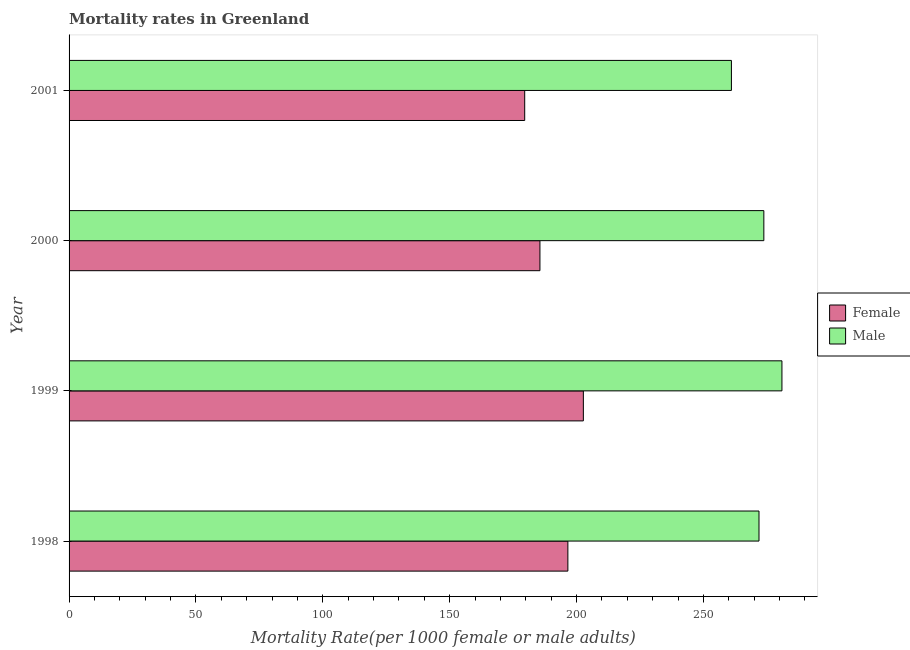How many groups of bars are there?
Offer a terse response. 4. What is the female mortality rate in 1998?
Your answer should be compact. 196.58. Across all years, what is the maximum male mortality rate?
Offer a terse response. 280.94. Across all years, what is the minimum male mortality rate?
Your response must be concise. 261.03. What is the total female mortality rate in the graph?
Your answer should be compact. 764.39. What is the difference between the male mortality rate in 1998 and that in 1999?
Your answer should be compact. -9.04. What is the difference between the female mortality rate in 1999 and the male mortality rate in 2000?
Your answer should be very brief. -71.13. What is the average female mortality rate per year?
Offer a very short reply. 191.1. In the year 1999, what is the difference between the male mortality rate and female mortality rate?
Your answer should be compact. 78.26. What is the ratio of the male mortality rate in 1998 to that in 2000?
Your answer should be compact. 0.99. What is the difference between the highest and the second highest female mortality rate?
Give a very brief answer. 6.1. What is the difference between the highest and the lowest female mortality rate?
Your answer should be compact. 23.11. In how many years, is the female mortality rate greater than the average female mortality rate taken over all years?
Your response must be concise. 2. Is the sum of the male mortality rate in 1999 and 2000 greater than the maximum female mortality rate across all years?
Provide a succinct answer. Yes. What does the 2nd bar from the top in 1998 represents?
Offer a terse response. Female. How many years are there in the graph?
Your answer should be compact. 4. Does the graph contain any zero values?
Your answer should be compact. No. Does the graph contain grids?
Your answer should be compact. No. How many legend labels are there?
Provide a short and direct response. 2. What is the title of the graph?
Your response must be concise. Mortality rates in Greenland. What is the label or title of the X-axis?
Offer a terse response. Mortality Rate(per 1000 female or male adults). What is the Mortality Rate(per 1000 female or male adults) of Female in 1998?
Make the answer very short. 196.58. What is the Mortality Rate(per 1000 female or male adults) of Male in 1998?
Make the answer very short. 271.9. What is the Mortality Rate(per 1000 female or male adults) of Female in 1999?
Your response must be concise. 202.68. What is the Mortality Rate(per 1000 female or male adults) of Male in 1999?
Provide a succinct answer. 280.94. What is the Mortality Rate(per 1000 female or male adults) in Female in 2000?
Offer a very short reply. 185.57. What is the Mortality Rate(per 1000 female or male adults) in Male in 2000?
Ensure brevity in your answer.  273.81. What is the Mortality Rate(per 1000 female or male adults) of Female in 2001?
Ensure brevity in your answer.  179.57. What is the Mortality Rate(per 1000 female or male adults) of Male in 2001?
Your answer should be very brief. 261.03. Across all years, what is the maximum Mortality Rate(per 1000 female or male adults) in Female?
Give a very brief answer. 202.68. Across all years, what is the maximum Mortality Rate(per 1000 female or male adults) of Male?
Your answer should be compact. 280.94. Across all years, what is the minimum Mortality Rate(per 1000 female or male adults) in Female?
Make the answer very short. 179.57. Across all years, what is the minimum Mortality Rate(per 1000 female or male adults) of Male?
Your answer should be very brief. 261.03. What is the total Mortality Rate(per 1000 female or male adults) in Female in the graph?
Make the answer very short. 764.39. What is the total Mortality Rate(per 1000 female or male adults) in Male in the graph?
Ensure brevity in your answer.  1087.69. What is the difference between the Mortality Rate(per 1000 female or male adults) in Female in 1998 and that in 1999?
Your response must be concise. -6.1. What is the difference between the Mortality Rate(per 1000 female or male adults) in Male in 1998 and that in 1999?
Offer a very short reply. -9.04. What is the difference between the Mortality Rate(per 1000 female or male adults) in Female in 1998 and that in 2000?
Offer a very short reply. 11.01. What is the difference between the Mortality Rate(per 1000 female or male adults) in Male in 1998 and that in 2000?
Keep it short and to the point. -1.91. What is the difference between the Mortality Rate(per 1000 female or male adults) of Female in 1998 and that in 2001?
Provide a succinct answer. 17.02. What is the difference between the Mortality Rate(per 1000 female or male adults) of Male in 1998 and that in 2001?
Give a very brief answer. 10.87. What is the difference between the Mortality Rate(per 1000 female or male adults) of Female in 1999 and that in 2000?
Ensure brevity in your answer.  17.11. What is the difference between the Mortality Rate(per 1000 female or male adults) in Male in 1999 and that in 2000?
Make the answer very short. 7.13. What is the difference between the Mortality Rate(per 1000 female or male adults) in Female in 1999 and that in 2001?
Your answer should be compact. 23.11. What is the difference between the Mortality Rate(per 1000 female or male adults) in Male in 1999 and that in 2001?
Make the answer very short. 19.91. What is the difference between the Mortality Rate(per 1000 female or male adults) of Female in 2000 and that in 2001?
Your answer should be compact. 6. What is the difference between the Mortality Rate(per 1000 female or male adults) of Male in 2000 and that in 2001?
Your answer should be very brief. 12.78. What is the difference between the Mortality Rate(per 1000 female or male adults) in Female in 1998 and the Mortality Rate(per 1000 female or male adults) in Male in 1999?
Offer a terse response. -84.36. What is the difference between the Mortality Rate(per 1000 female or male adults) in Female in 1998 and the Mortality Rate(per 1000 female or male adults) in Male in 2000?
Your answer should be compact. -77.23. What is the difference between the Mortality Rate(per 1000 female or male adults) in Female in 1998 and the Mortality Rate(per 1000 female or male adults) in Male in 2001?
Offer a very short reply. -64.45. What is the difference between the Mortality Rate(per 1000 female or male adults) in Female in 1999 and the Mortality Rate(per 1000 female or male adults) in Male in 2000?
Provide a succinct answer. -71.13. What is the difference between the Mortality Rate(per 1000 female or male adults) of Female in 1999 and the Mortality Rate(per 1000 female or male adults) of Male in 2001?
Provide a short and direct response. -58.35. What is the difference between the Mortality Rate(per 1000 female or male adults) of Female in 2000 and the Mortality Rate(per 1000 female or male adults) of Male in 2001?
Make the answer very short. -75.46. What is the average Mortality Rate(per 1000 female or male adults) in Female per year?
Provide a short and direct response. 191.1. What is the average Mortality Rate(per 1000 female or male adults) in Male per year?
Make the answer very short. 271.92. In the year 1998, what is the difference between the Mortality Rate(per 1000 female or male adults) in Female and Mortality Rate(per 1000 female or male adults) in Male?
Give a very brief answer. -75.32. In the year 1999, what is the difference between the Mortality Rate(per 1000 female or male adults) in Female and Mortality Rate(per 1000 female or male adults) in Male?
Your answer should be very brief. -78.26. In the year 2000, what is the difference between the Mortality Rate(per 1000 female or male adults) in Female and Mortality Rate(per 1000 female or male adults) in Male?
Keep it short and to the point. -88.24. In the year 2001, what is the difference between the Mortality Rate(per 1000 female or male adults) of Female and Mortality Rate(per 1000 female or male adults) of Male?
Make the answer very short. -81.47. What is the ratio of the Mortality Rate(per 1000 female or male adults) of Female in 1998 to that in 1999?
Your answer should be compact. 0.97. What is the ratio of the Mortality Rate(per 1000 female or male adults) in Male in 1998 to that in 1999?
Offer a terse response. 0.97. What is the ratio of the Mortality Rate(per 1000 female or male adults) in Female in 1998 to that in 2000?
Give a very brief answer. 1.06. What is the ratio of the Mortality Rate(per 1000 female or male adults) in Male in 1998 to that in 2000?
Make the answer very short. 0.99. What is the ratio of the Mortality Rate(per 1000 female or male adults) of Female in 1998 to that in 2001?
Your answer should be compact. 1.09. What is the ratio of the Mortality Rate(per 1000 female or male adults) of Male in 1998 to that in 2001?
Offer a terse response. 1.04. What is the ratio of the Mortality Rate(per 1000 female or male adults) of Female in 1999 to that in 2000?
Your answer should be compact. 1.09. What is the ratio of the Mortality Rate(per 1000 female or male adults) of Male in 1999 to that in 2000?
Your response must be concise. 1.03. What is the ratio of the Mortality Rate(per 1000 female or male adults) of Female in 1999 to that in 2001?
Make the answer very short. 1.13. What is the ratio of the Mortality Rate(per 1000 female or male adults) in Male in 1999 to that in 2001?
Ensure brevity in your answer.  1.08. What is the ratio of the Mortality Rate(per 1000 female or male adults) of Female in 2000 to that in 2001?
Provide a succinct answer. 1.03. What is the ratio of the Mortality Rate(per 1000 female or male adults) in Male in 2000 to that in 2001?
Give a very brief answer. 1.05. What is the difference between the highest and the second highest Mortality Rate(per 1000 female or male adults) of Female?
Provide a succinct answer. 6.1. What is the difference between the highest and the second highest Mortality Rate(per 1000 female or male adults) of Male?
Ensure brevity in your answer.  7.13. What is the difference between the highest and the lowest Mortality Rate(per 1000 female or male adults) in Female?
Provide a succinct answer. 23.11. What is the difference between the highest and the lowest Mortality Rate(per 1000 female or male adults) of Male?
Provide a short and direct response. 19.91. 